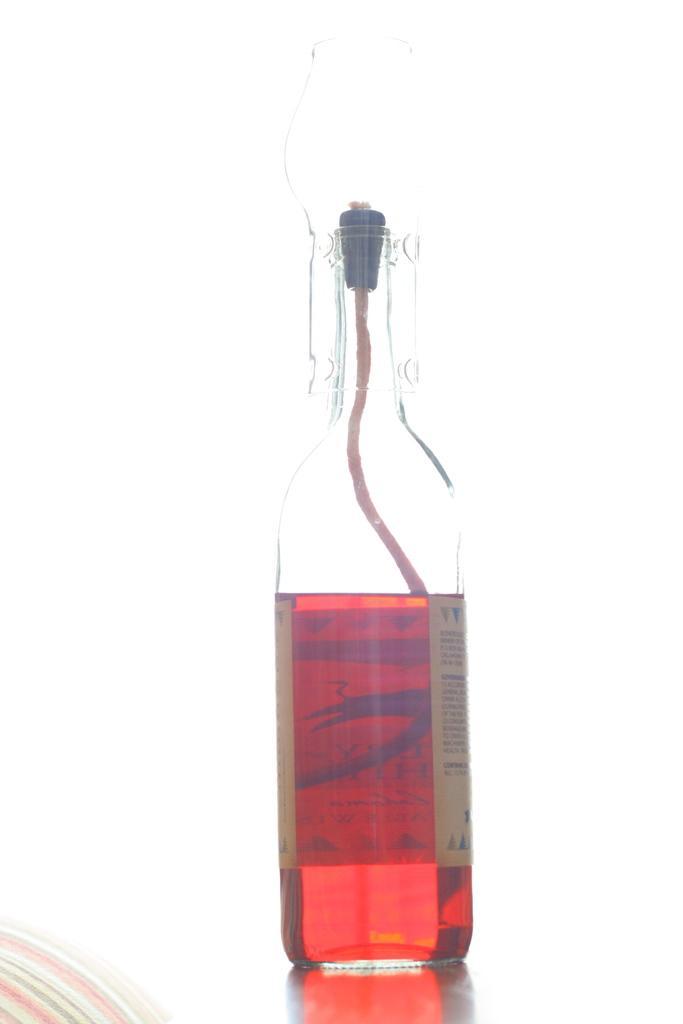Could you give a brief overview of what you see in this image? There is a bottle which has red drink in it. 